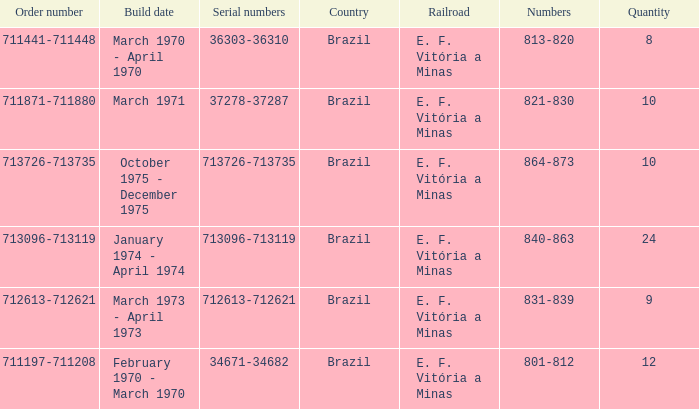How many railroads have the numbers 864-873? 1.0. 